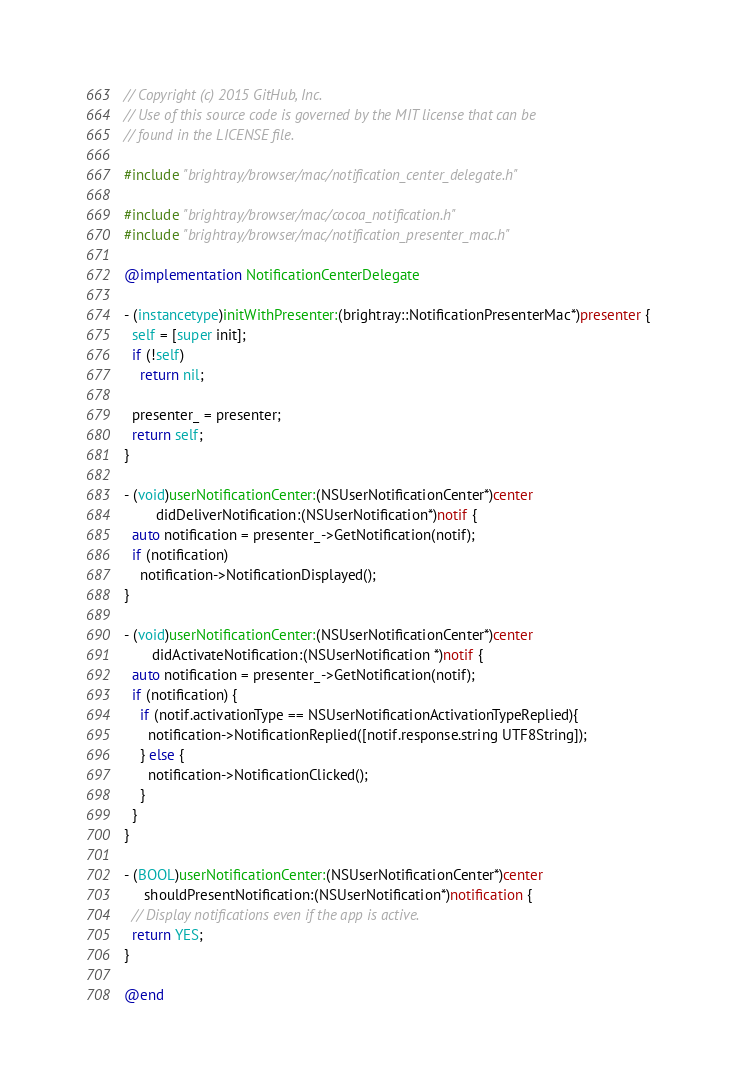Convert code to text. <code><loc_0><loc_0><loc_500><loc_500><_ObjectiveC_>// Copyright (c) 2015 GitHub, Inc.
// Use of this source code is governed by the MIT license that can be
// found in the LICENSE file.

#include "brightray/browser/mac/notification_center_delegate.h"

#include "brightray/browser/mac/cocoa_notification.h"
#include "brightray/browser/mac/notification_presenter_mac.h"

@implementation NotificationCenterDelegate

- (instancetype)initWithPresenter:(brightray::NotificationPresenterMac*)presenter {
  self = [super init];
  if (!self)
    return nil;

  presenter_ = presenter;
  return self;
}

- (void)userNotificationCenter:(NSUserNotificationCenter*)center
        didDeliverNotification:(NSUserNotification*)notif {
  auto notification = presenter_->GetNotification(notif);
  if (notification)
    notification->NotificationDisplayed();
}

- (void)userNotificationCenter:(NSUserNotificationCenter*)center
       didActivateNotification:(NSUserNotification *)notif {
  auto notification = presenter_->GetNotification(notif);
  if (notification) {
    if (notif.activationType == NSUserNotificationActivationTypeReplied){
      notification->NotificationReplied([notif.response.string UTF8String]);
    } else {
      notification->NotificationClicked(); 
    }
  }
}

- (BOOL)userNotificationCenter:(NSUserNotificationCenter*)center
     shouldPresentNotification:(NSUserNotification*)notification {
  // Display notifications even if the app is active.
  return YES;
}

@end
</code> 